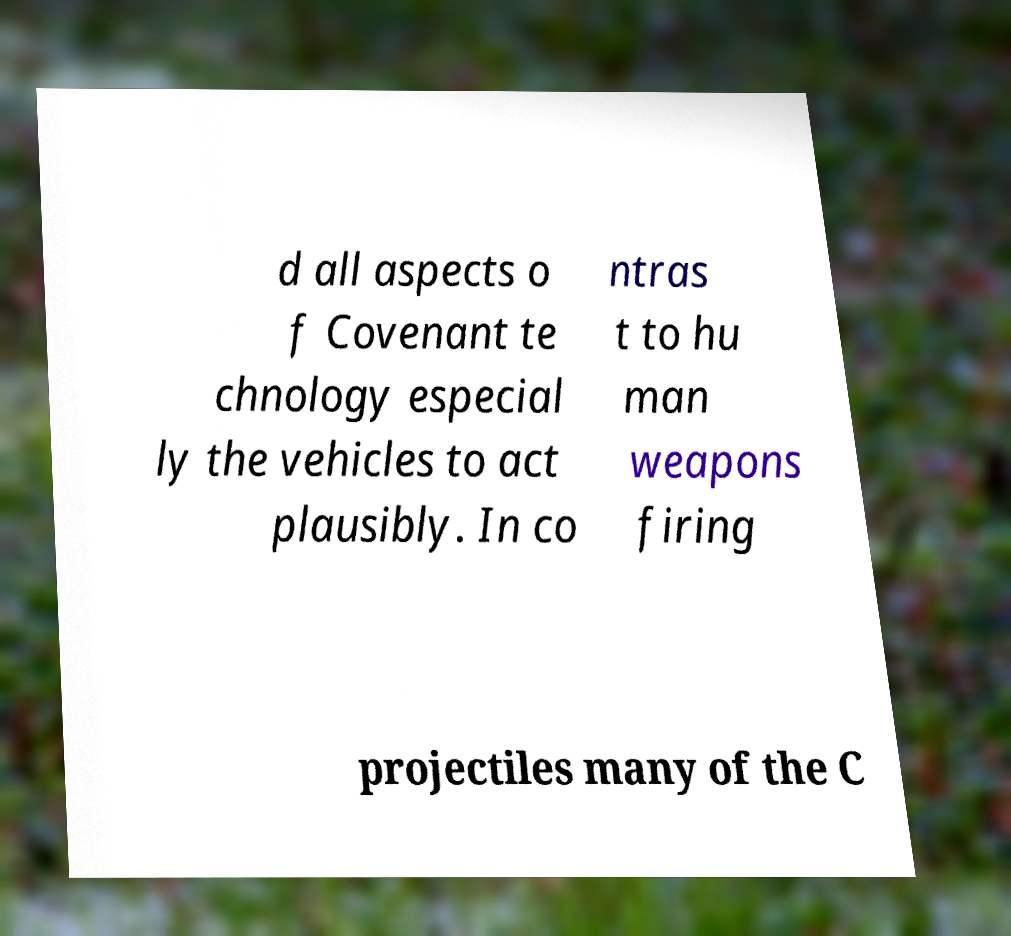Could you extract and type out the text from this image? d all aspects o f Covenant te chnology especial ly the vehicles to act plausibly. In co ntras t to hu man weapons firing projectiles many of the C 